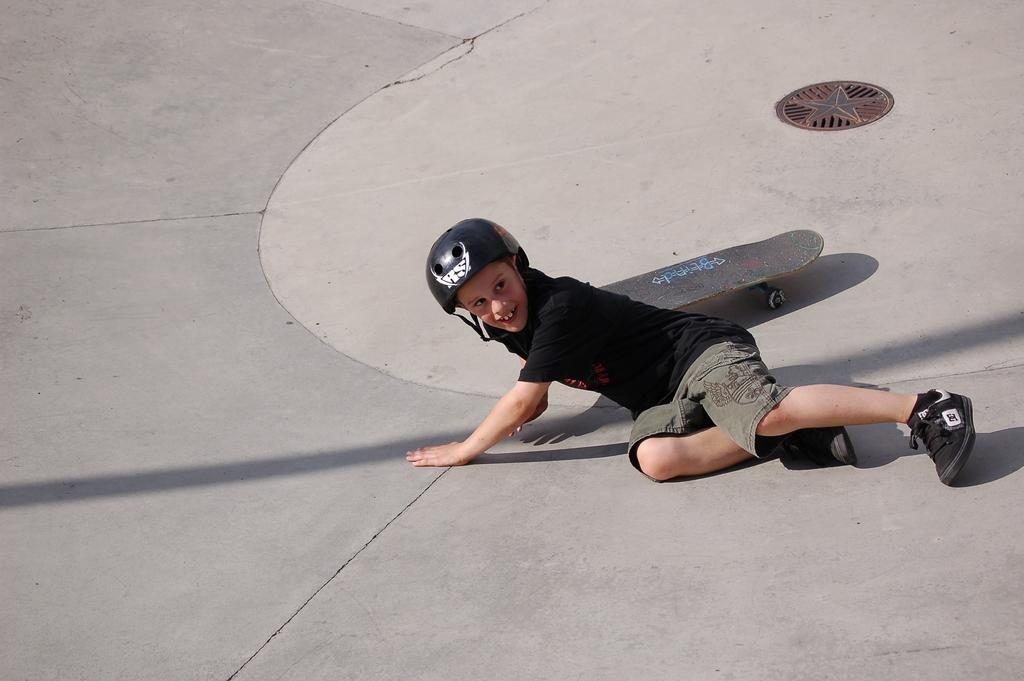What is the main subject of the picture? The main subject of the picture is a kid. What is the kid doing in the image? The kid is smiling in the image. What protective gear is the kid wearing? The kid is wearing a helmet in the image. What type of footwear is the kid wearing? The kid is wearing shoes in the image. What object is located in the middle of the image? There is a skateboard in the middle of the image. What can be seen on the left side of the image? There is a shadow of a pole on the left side of the image. What type of knife is the kid holding in the image? There is no knife present in the image; the kid is wearing a helmet and shoes, and there is a skateboard in the middle of the image. Are there any police officers visible in the image? There are no police officers present in the image. 